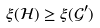Convert formula to latex. <formula><loc_0><loc_0><loc_500><loc_500>\xi ( { \mathcal { H } } ) \geq \xi ( { \mathcal { G } } ^ { \prime } )</formula> 